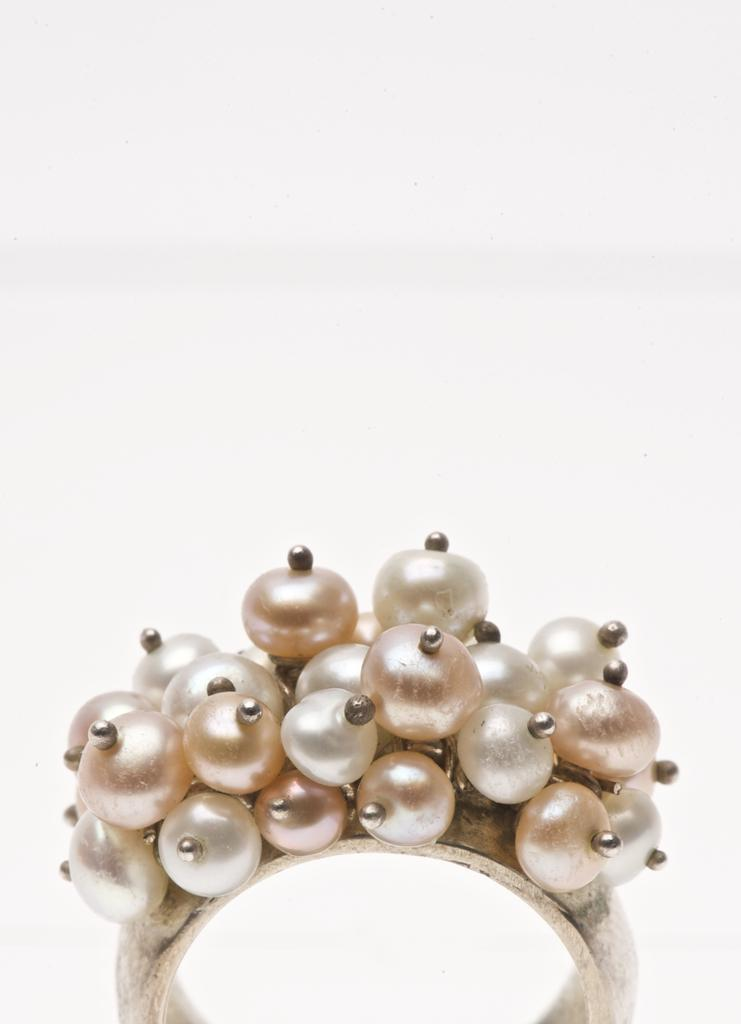What type of jewelry is featured in the image? There is a hand ring in the image. What material is the hand ring made of? The hand ring is made of pearls. What type of record can be seen in the image? There is no record present in the image; it features a hand ring made of pearls. How many women are visible in the image? There are no women visible in the image; it only features a hand ring made of pearls. 